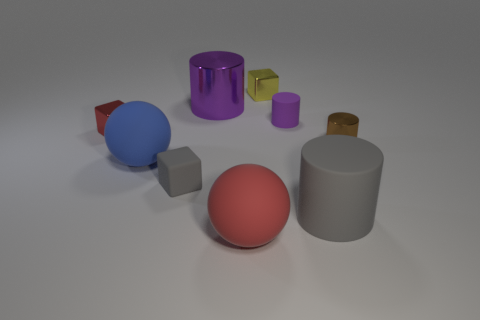Subtract all tiny purple matte cylinders. How many cylinders are left? 3 Subtract all purple cubes. How many purple cylinders are left? 2 Subtract 1 spheres. How many spheres are left? 1 Subtract all purple cylinders. How many cylinders are left? 2 Subtract all cubes. How many objects are left? 6 Add 7 yellow things. How many yellow things exist? 8 Subtract 1 red spheres. How many objects are left? 8 Subtract all green spheres. Subtract all brown cylinders. How many spheres are left? 2 Subtract all big purple objects. Subtract all small gray rubber cylinders. How many objects are left? 8 Add 8 blue rubber things. How many blue rubber things are left? 9 